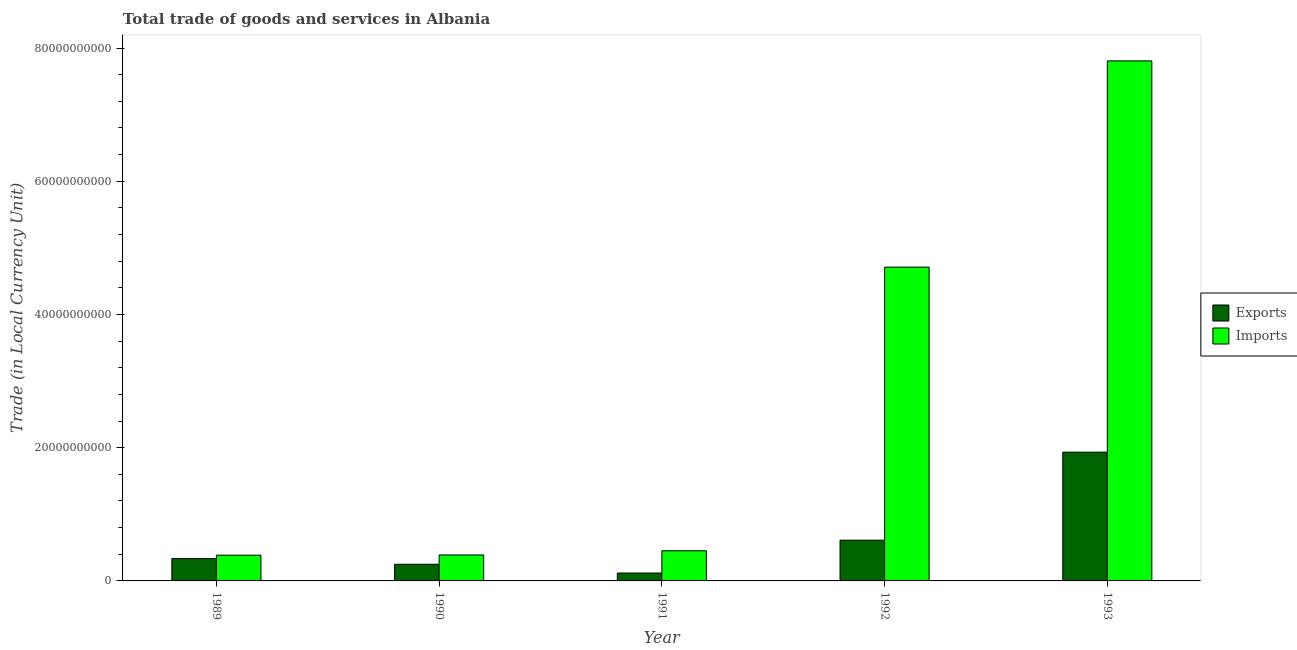Are the number of bars per tick equal to the number of legend labels?
Provide a succinct answer. Yes. How many bars are there on the 2nd tick from the right?
Provide a succinct answer. 2. What is the label of the 1st group of bars from the left?
Your response must be concise. 1989. In how many cases, is the number of bars for a given year not equal to the number of legend labels?
Provide a succinct answer. 0. What is the imports of goods and services in 1991?
Your response must be concise. 4.53e+09. Across all years, what is the maximum imports of goods and services?
Give a very brief answer. 7.81e+1. Across all years, what is the minimum imports of goods and services?
Your answer should be very brief. 3.87e+09. In which year was the imports of goods and services minimum?
Keep it short and to the point. 1989. What is the total export of goods and services in the graph?
Make the answer very short. 3.25e+1. What is the difference between the imports of goods and services in 1990 and that in 1992?
Give a very brief answer. -4.32e+1. What is the difference between the export of goods and services in 1989 and the imports of goods and services in 1991?
Make the answer very short. 2.17e+09. What is the average export of goods and services per year?
Give a very brief answer. 6.50e+09. What is the ratio of the imports of goods and services in 1990 to that in 1991?
Provide a short and direct response. 0.86. What is the difference between the highest and the second highest imports of goods and services?
Your response must be concise. 3.10e+1. What is the difference between the highest and the lowest export of goods and services?
Keep it short and to the point. 1.81e+1. In how many years, is the export of goods and services greater than the average export of goods and services taken over all years?
Offer a terse response. 1. What does the 2nd bar from the left in 1990 represents?
Your response must be concise. Imports. What does the 1st bar from the right in 1993 represents?
Keep it short and to the point. Imports. How many bars are there?
Give a very brief answer. 10. What is the difference between two consecutive major ticks on the Y-axis?
Offer a terse response. 2.00e+1. Does the graph contain any zero values?
Ensure brevity in your answer.  No. How many legend labels are there?
Your response must be concise. 2. How are the legend labels stacked?
Your answer should be very brief. Vertical. What is the title of the graph?
Offer a very short reply. Total trade of goods and services in Albania. Does "Primary income" appear as one of the legend labels in the graph?
Your answer should be compact. No. What is the label or title of the Y-axis?
Your answer should be very brief. Trade (in Local Currency Unit). What is the Trade (in Local Currency Unit) in Exports in 1989?
Ensure brevity in your answer.  3.35e+09. What is the Trade (in Local Currency Unit) of Imports in 1989?
Provide a short and direct response. 3.87e+09. What is the Trade (in Local Currency Unit) in Exports in 1990?
Ensure brevity in your answer.  2.50e+09. What is the Trade (in Local Currency Unit) of Imports in 1990?
Provide a succinct answer. 3.90e+09. What is the Trade (in Local Currency Unit) in Exports in 1991?
Provide a short and direct response. 1.19e+09. What is the Trade (in Local Currency Unit) of Imports in 1991?
Offer a very short reply. 4.53e+09. What is the Trade (in Local Currency Unit) of Exports in 1992?
Keep it short and to the point. 6.12e+09. What is the Trade (in Local Currency Unit) of Imports in 1992?
Offer a terse response. 4.71e+1. What is the Trade (in Local Currency Unit) in Exports in 1993?
Offer a very short reply. 1.93e+1. What is the Trade (in Local Currency Unit) in Imports in 1993?
Your answer should be very brief. 7.81e+1. Across all years, what is the maximum Trade (in Local Currency Unit) of Exports?
Your answer should be very brief. 1.93e+1. Across all years, what is the maximum Trade (in Local Currency Unit) in Imports?
Keep it short and to the point. 7.81e+1. Across all years, what is the minimum Trade (in Local Currency Unit) in Exports?
Your response must be concise. 1.19e+09. Across all years, what is the minimum Trade (in Local Currency Unit) of Imports?
Offer a very short reply. 3.87e+09. What is the total Trade (in Local Currency Unit) in Exports in the graph?
Offer a terse response. 3.25e+1. What is the total Trade (in Local Currency Unit) in Imports in the graph?
Make the answer very short. 1.37e+11. What is the difference between the Trade (in Local Currency Unit) in Exports in 1989 and that in 1990?
Provide a short and direct response. 8.51e+08. What is the difference between the Trade (in Local Currency Unit) in Imports in 1989 and that in 1990?
Provide a succinct answer. -2.96e+07. What is the difference between the Trade (in Local Currency Unit) in Exports in 1989 and that in 1991?
Provide a short and direct response. 2.17e+09. What is the difference between the Trade (in Local Currency Unit) in Imports in 1989 and that in 1991?
Provide a succinct answer. -6.56e+08. What is the difference between the Trade (in Local Currency Unit) of Exports in 1989 and that in 1992?
Your answer should be compact. -2.77e+09. What is the difference between the Trade (in Local Currency Unit) in Imports in 1989 and that in 1992?
Provide a short and direct response. -4.32e+1. What is the difference between the Trade (in Local Currency Unit) of Exports in 1989 and that in 1993?
Your response must be concise. -1.60e+1. What is the difference between the Trade (in Local Currency Unit) of Imports in 1989 and that in 1993?
Provide a succinct answer. -7.42e+1. What is the difference between the Trade (in Local Currency Unit) of Exports in 1990 and that in 1991?
Make the answer very short. 1.31e+09. What is the difference between the Trade (in Local Currency Unit) in Imports in 1990 and that in 1991?
Give a very brief answer. -6.26e+08. What is the difference between the Trade (in Local Currency Unit) in Exports in 1990 and that in 1992?
Your response must be concise. -3.62e+09. What is the difference between the Trade (in Local Currency Unit) of Imports in 1990 and that in 1992?
Make the answer very short. -4.32e+1. What is the difference between the Trade (in Local Currency Unit) in Exports in 1990 and that in 1993?
Give a very brief answer. -1.68e+1. What is the difference between the Trade (in Local Currency Unit) in Imports in 1990 and that in 1993?
Your response must be concise. -7.42e+1. What is the difference between the Trade (in Local Currency Unit) of Exports in 1991 and that in 1992?
Your answer should be compact. -4.93e+09. What is the difference between the Trade (in Local Currency Unit) in Imports in 1991 and that in 1992?
Ensure brevity in your answer.  -4.26e+1. What is the difference between the Trade (in Local Currency Unit) of Exports in 1991 and that in 1993?
Your answer should be compact. -1.81e+1. What is the difference between the Trade (in Local Currency Unit) of Imports in 1991 and that in 1993?
Give a very brief answer. -7.36e+1. What is the difference between the Trade (in Local Currency Unit) in Exports in 1992 and that in 1993?
Your answer should be compact. -1.32e+1. What is the difference between the Trade (in Local Currency Unit) in Imports in 1992 and that in 1993?
Make the answer very short. -3.10e+1. What is the difference between the Trade (in Local Currency Unit) of Exports in 1989 and the Trade (in Local Currency Unit) of Imports in 1990?
Ensure brevity in your answer.  -5.49e+08. What is the difference between the Trade (in Local Currency Unit) of Exports in 1989 and the Trade (in Local Currency Unit) of Imports in 1991?
Your answer should be very brief. -1.17e+09. What is the difference between the Trade (in Local Currency Unit) in Exports in 1989 and the Trade (in Local Currency Unit) in Imports in 1992?
Keep it short and to the point. -4.38e+1. What is the difference between the Trade (in Local Currency Unit) in Exports in 1989 and the Trade (in Local Currency Unit) in Imports in 1993?
Offer a terse response. -7.47e+1. What is the difference between the Trade (in Local Currency Unit) in Exports in 1990 and the Trade (in Local Currency Unit) in Imports in 1991?
Offer a terse response. -2.03e+09. What is the difference between the Trade (in Local Currency Unit) in Exports in 1990 and the Trade (in Local Currency Unit) in Imports in 1992?
Provide a succinct answer. -4.46e+1. What is the difference between the Trade (in Local Currency Unit) in Exports in 1990 and the Trade (in Local Currency Unit) in Imports in 1993?
Provide a succinct answer. -7.56e+1. What is the difference between the Trade (in Local Currency Unit) in Exports in 1991 and the Trade (in Local Currency Unit) in Imports in 1992?
Provide a succinct answer. -4.59e+1. What is the difference between the Trade (in Local Currency Unit) of Exports in 1991 and the Trade (in Local Currency Unit) of Imports in 1993?
Offer a very short reply. -7.69e+1. What is the difference between the Trade (in Local Currency Unit) of Exports in 1992 and the Trade (in Local Currency Unit) of Imports in 1993?
Your answer should be compact. -7.20e+1. What is the average Trade (in Local Currency Unit) of Exports per year?
Keep it short and to the point. 6.50e+09. What is the average Trade (in Local Currency Unit) in Imports per year?
Provide a short and direct response. 2.75e+1. In the year 1989, what is the difference between the Trade (in Local Currency Unit) in Exports and Trade (in Local Currency Unit) in Imports?
Offer a terse response. -5.19e+08. In the year 1990, what is the difference between the Trade (in Local Currency Unit) in Exports and Trade (in Local Currency Unit) in Imports?
Provide a succinct answer. -1.40e+09. In the year 1991, what is the difference between the Trade (in Local Currency Unit) of Exports and Trade (in Local Currency Unit) of Imports?
Ensure brevity in your answer.  -3.34e+09. In the year 1992, what is the difference between the Trade (in Local Currency Unit) of Exports and Trade (in Local Currency Unit) of Imports?
Provide a succinct answer. -4.10e+1. In the year 1993, what is the difference between the Trade (in Local Currency Unit) of Exports and Trade (in Local Currency Unit) of Imports?
Your answer should be compact. -5.87e+1. What is the ratio of the Trade (in Local Currency Unit) in Exports in 1989 to that in 1990?
Make the answer very short. 1.34. What is the ratio of the Trade (in Local Currency Unit) of Imports in 1989 to that in 1990?
Offer a very short reply. 0.99. What is the ratio of the Trade (in Local Currency Unit) of Exports in 1989 to that in 1991?
Give a very brief answer. 2.83. What is the ratio of the Trade (in Local Currency Unit) of Imports in 1989 to that in 1991?
Provide a succinct answer. 0.86. What is the ratio of the Trade (in Local Currency Unit) in Exports in 1989 to that in 1992?
Offer a terse response. 0.55. What is the ratio of the Trade (in Local Currency Unit) of Imports in 1989 to that in 1992?
Offer a very short reply. 0.08. What is the ratio of the Trade (in Local Currency Unit) in Exports in 1989 to that in 1993?
Give a very brief answer. 0.17. What is the ratio of the Trade (in Local Currency Unit) in Imports in 1989 to that in 1993?
Your response must be concise. 0.05. What is the ratio of the Trade (in Local Currency Unit) in Exports in 1990 to that in 1991?
Your answer should be compact. 2.11. What is the ratio of the Trade (in Local Currency Unit) in Imports in 1990 to that in 1991?
Your response must be concise. 0.86. What is the ratio of the Trade (in Local Currency Unit) of Exports in 1990 to that in 1992?
Your answer should be compact. 0.41. What is the ratio of the Trade (in Local Currency Unit) of Imports in 1990 to that in 1992?
Give a very brief answer. 0.08. What is the ratio of the Trade (in Local Currency Unit) of Exports in 1990 to that in 1993?
Offer a terse response. 0.13. What is the ratio of the Trade (in Local Currency Unit) of Imports in 1990 to that in 1993?
Keep it short and to the point. 0.05. What is the ratio of the Trade (in Local Currency Unit) of Exports in 1991 to that in 1992?
Your answer should be compact. 0.19. What is the ratio of the Trade (in Local Currency Unit) in Imports in 1991 to that in 1992?
Keep it short and to the point. 0.1. What is the ratio of the Trade (in Local Currency Unit) in Exports in 1991 to that in 1993?
Make the answer very short. 0.06. What is the ratio of the Trade (in Local Currency Unit) of Imports in 1991 to that in 1993?
Make the answer very short. 0.06. What is the ratio of the Trade (in Local Currency Unit) in Exports in 1992 to that in 1993?
Provide a succinct answer. 0.32. What is the ratio of the Trade (in Local Currency Unit) in Imports in 1992 to that in 1993?
Make the answer very short. 0.6. What is the difference between the highest and the second highest Trade (in Local Currency Unit) in Exports?
Offer a terse response. 1.32e+1. What is the difference between the highest and the second highest Trade (in Local Currency Unit) in Imports?
Offer a very short reply. 3.10e+1. What is the difference between the highest and the lowest Trade (in Local Currency Unit) of Exports?
Your response must be concise. 1.81e+1. What is the difference between the highest and the lowest Trade (in Local Currency Unit) in Imports?
Give a very brief answer. 7.42e+1. 